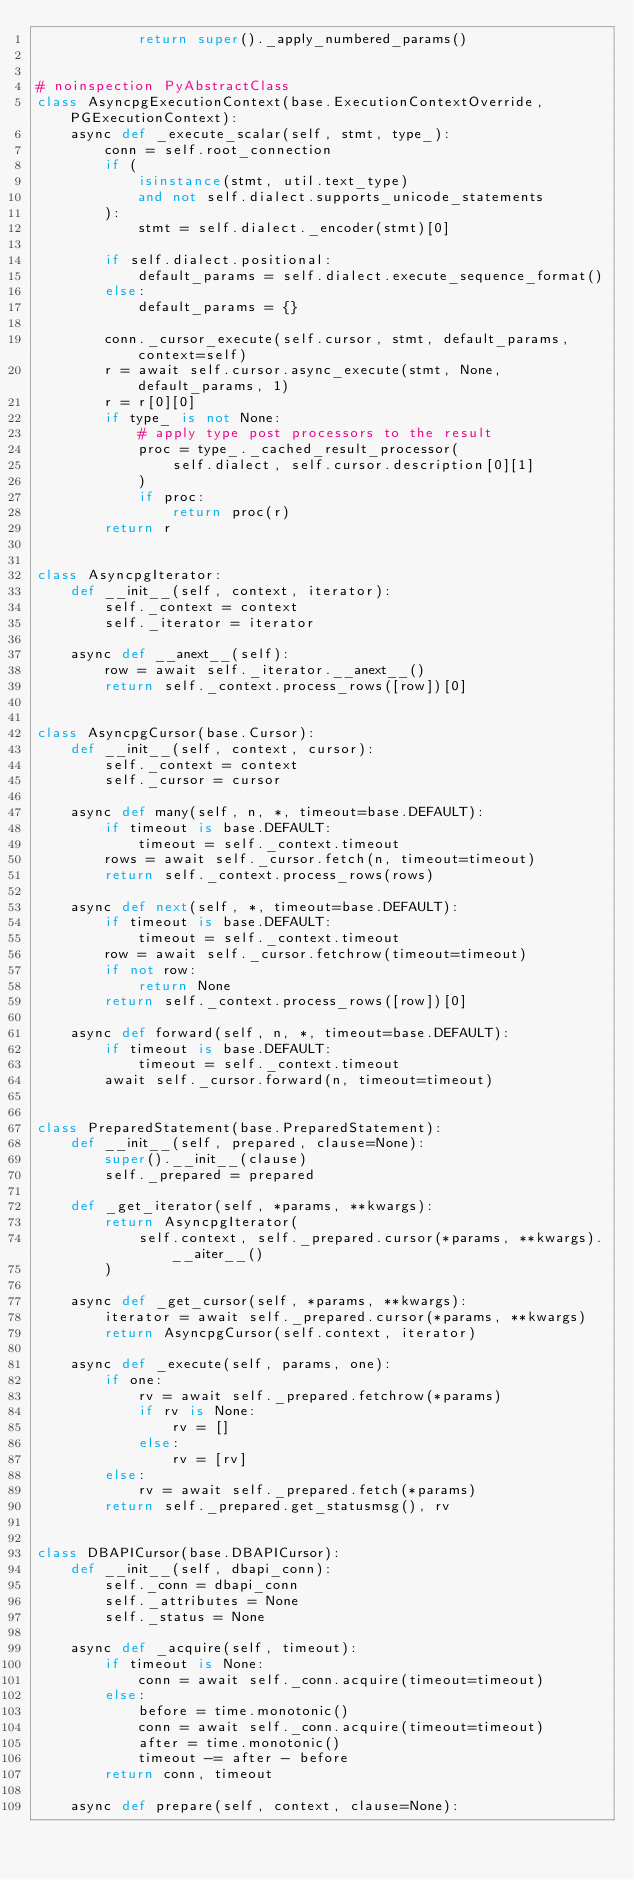<code> <loc_0><loc_0><loc_500><loc_500><_Python_>            return super()._apply_numbered_params()


# noinspection PyAbstractClass
class AsyncpgExecutionContext(base.ExecutionContextOverride, PGExecutionContext):
    async def _execute_scalar(self, stmt, type_):
        conn = self.root_connection
        if (
            isinstance(stmt, util.text_type)
            and not self.dialect.supports_unicode_statements
        ):
            stmt = self.dialect._encoder(stmt)[0]

        if self.dialect.positional:
            default_params = self.dialect.execute_sequence_format()
        else:
            default_params = {}

        conn._cursor_execute(self.cursor, stmt, default_params, context=self)
        r = await self.cursor.async_execute(stmt, None, default_params, 1)
        r = r[0][0]
        if type_ is not None:
            # apply type post processors to the result
            proc = type_._cached_result_processor(
                self.dialect, self.cursor.description[0][1]
            )
            if proc:
                return proc(r)
        return r


class AsyncpgIterator:
    def __init__(self, context, iterator):
        self._context = context
        self._iterator = iterator

    async def __anext__(self):
        row = await self._iterator.__anext__()
        return self._context.process_rows([row])[0]


class AsyncpgCursor(base.Cursor):
    def __init__(self, context, cursor):
        self._context = context
        self._cursor = cursor

    async def many(self, n, *, timeout=base.DEFAULT):
        if timeout is base.DEFAULT:
            timeout = self._context.timeout
        rows = await self._cursor.fetch(n, timeout=timeout)
        return self._context.process_rows(rows)

    async def next(self, *, timeout=base.DEFAULT):
        if timeout is base.DEFAULT:
            timeout = self._context.timeout
        row = await self._cursor.fetchrow(timeout=timeout)
        if not row:
            return None
        return self._context.process_rows([row])[0]

    async def forward(self, n, *, timeout=base.DEFAULT):
        if timeout is base.DEFAULT:
            timeout = self._context.timeout
        await self._cursor.forward(n, timeout=timeout)


class PreparedStatement(base.PreparedStatement):
    def __init__(self, prepared, clause=None):
        super().__init__(clause)
        self._prepared = prepared

    def _get_iterator(self, *params, **kwargs):
        return AsyncpgIterator(
            self.context, self._prepared.cursor(*params, **kwargs).__aiter__()
        )

    async def _get_cursor(self, *params, **kwargs):
        iterator = await self._prepared.cursor(*params, **kwargs)
        return AsyncpgCursor(self.context, iterator)

    async def _execute(self, params, one):
        if one:
            rv = await self._prepared.fetchrow(*params)
            if rv is None:
                rv = []
            else:
                rv = [rv]
        else:
            rv = await self._prepared.fetch(*params)
        return self._prepared.get_statusmsg(), rv


class DBAPICursor(base.DBAPICursor):
    def __init__(self, dbapi_conn):
        self._conn = dbapi_conn
        self._attributes = None
        self._status = None

    async def _acquire(self, timeout):
        if timeout is None:
            conn = await self._conn.acquire(timeout=timeout)
        else:
            before = time.monotonic()
            conn = await self._conn.acquire(timeout=timeout)
            after = time.monotonic()
            timeout -= after - before
        return conn, timeout

    async def prepare(self, context, clause=None):</code> 